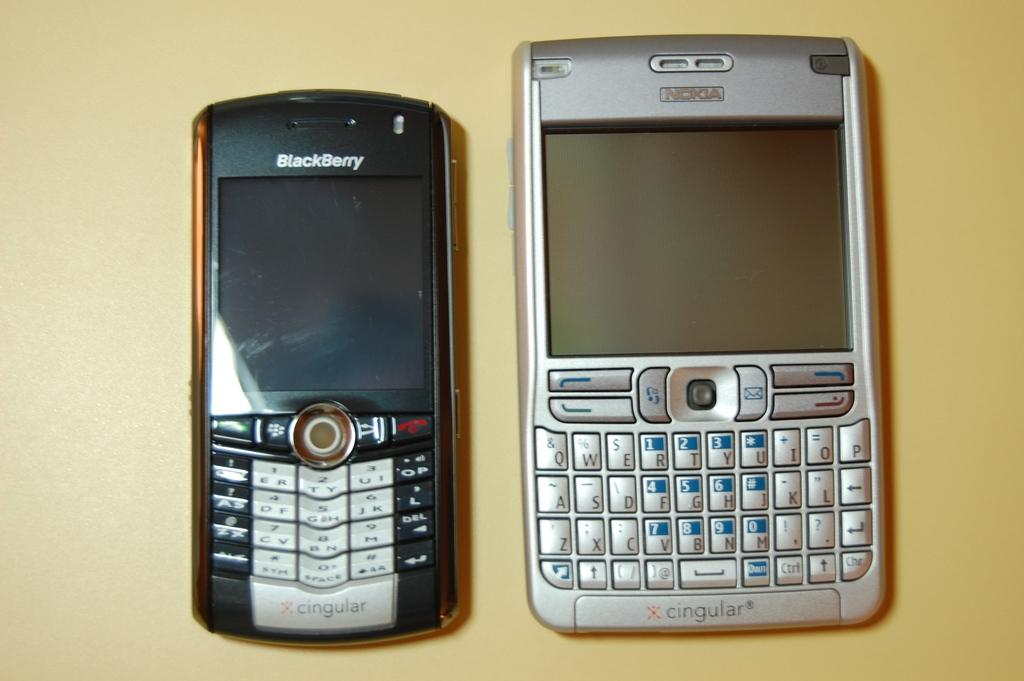<image>
Summarize the visual content of the image. Two old models of both Blackberry and Nokia technology. 